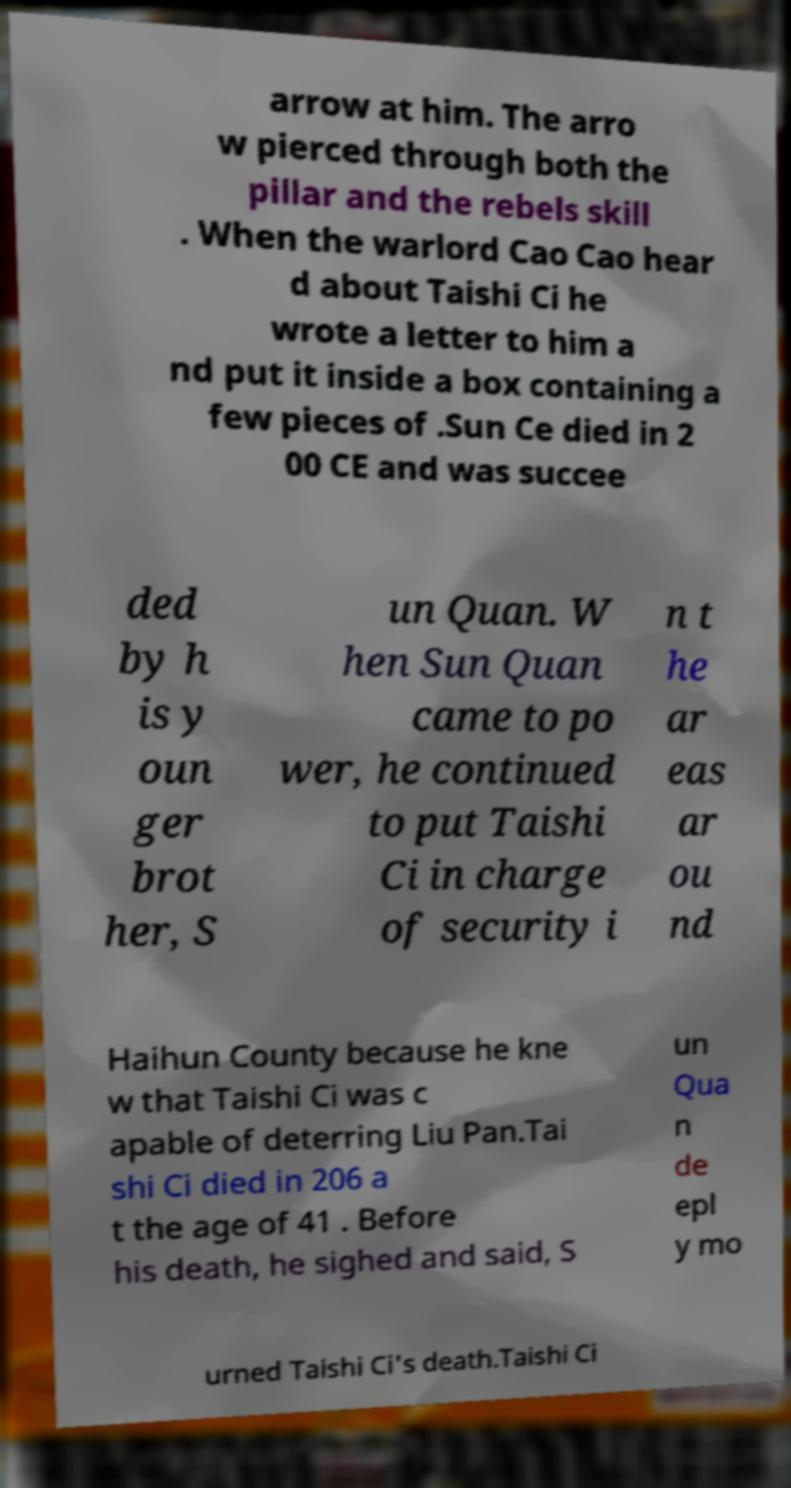Please read and relay the text visible in this image. What does it say? arrow at him. The arro w pierced through both the pillar and the rebels skill . When the warlord Cao Cao hear d about Taishi Ci he wrote a letter to him a nd put it inside a box containing a few pieces of .Sun Ce died in 2 00 CE and was succee ded by h is y oun ger brot her, S un Quan. W hen Sun Quan came to po wer, he continued to put Taishi Ci in charge of security i n t he ar eas ar ou nd Haihun County because he kne w that Taishi Ci was c apable of deterring Liu Pan.Tai shi Ci died in 206 a t the age of 41 . Before his death, he sighed and said, S un Qua n de epl y mo urned Taishi Ci's death.Taishi Ci 